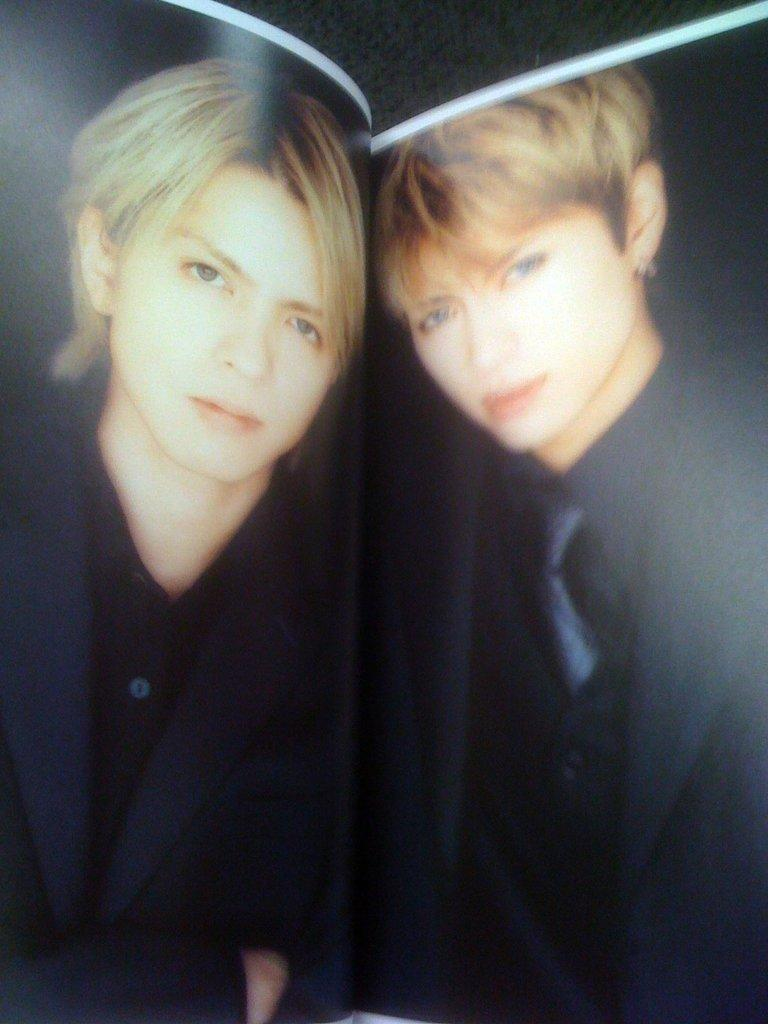What is depicted in the image? There are two photos of people in the image. What can be observed about the people in the photos? The people in the photos are wearing clothes. How would you describe the overall appearance of the image? The background of the image is dark. Can you tell me how many secretaries are visible in the image? There are no secretaries present in the image; it features two photos of people. What type of window can be seen in the image? There is no window present in the image; it consists of two photos of people with a dark background. 